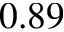Convert formula to latex. <formula><loc_0><loc_0><loc_500><loc_500>0 . 8 9</formula> 